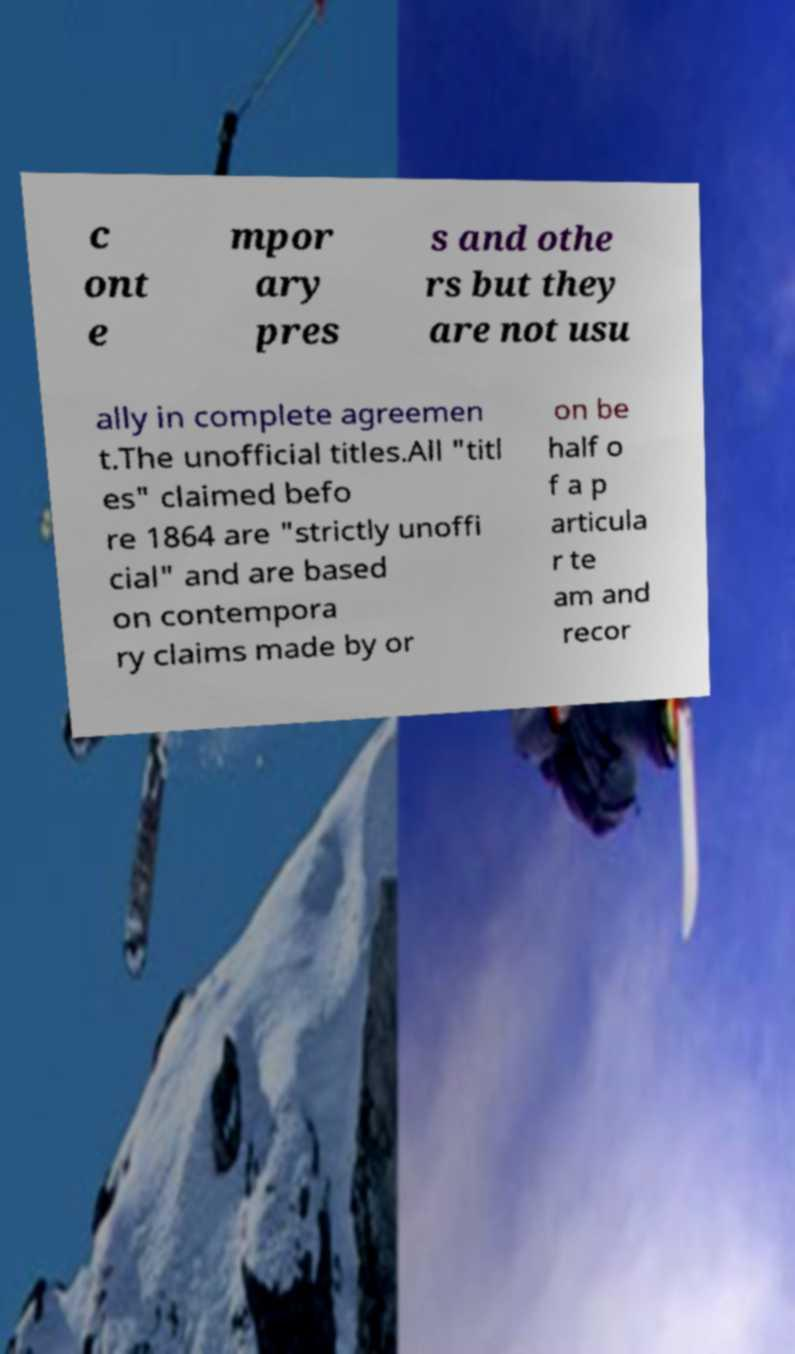Please read and relay the text visible in this image. What does it say? c ont e mpor ary pres s and othe rs but they are not usu ally in complete agreemen t.The unofficial titles.All "titl es" claimed befo re 1864 are "strictly unoffi cial" and are based on contempora ry claims made by or on be half o f a p articula r te am and recor 